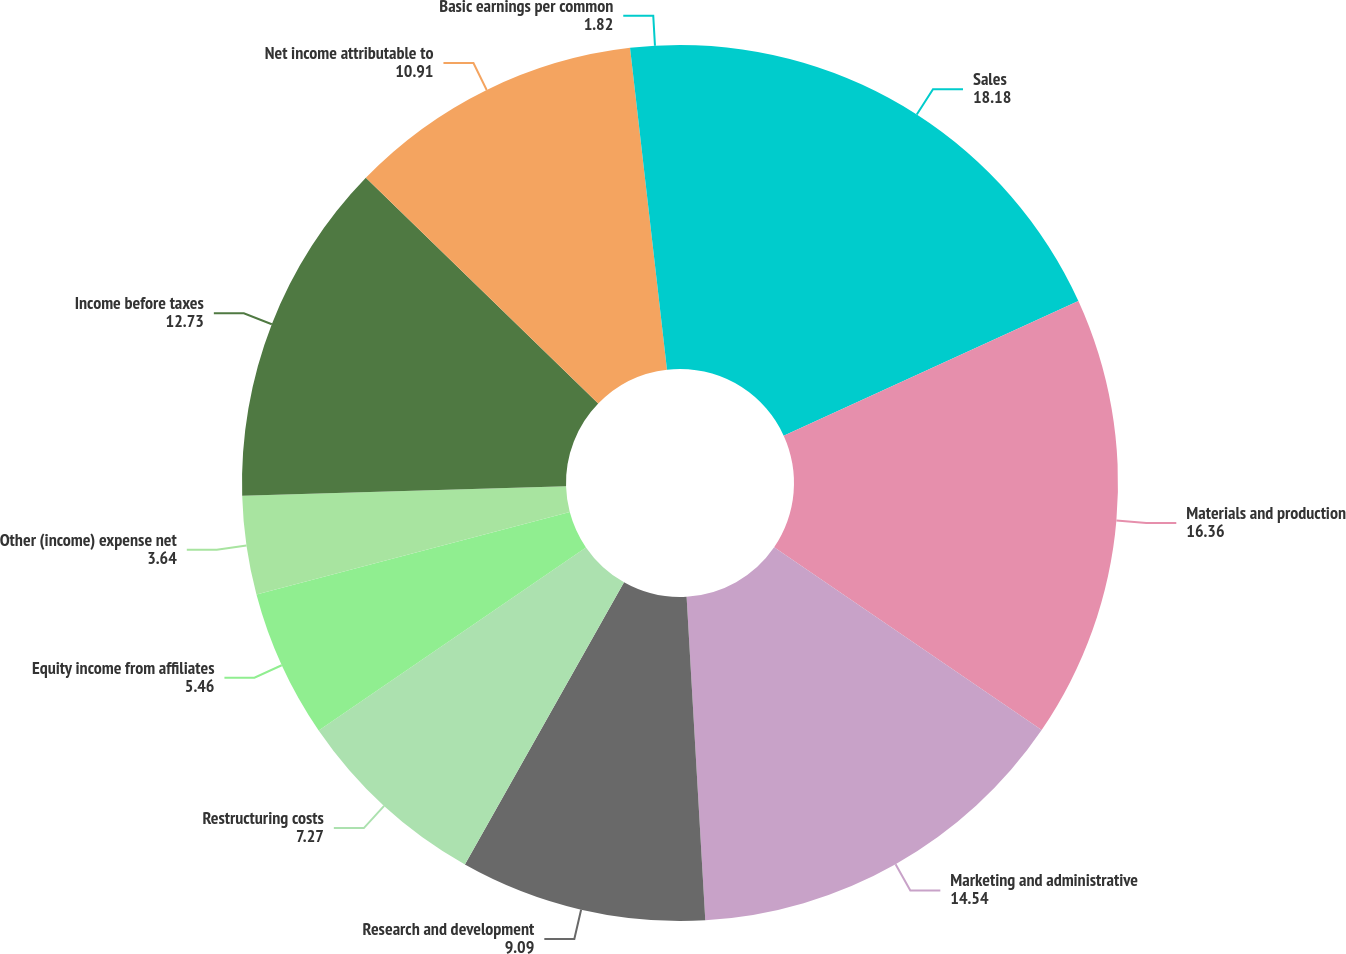Convert chart to OTSL. <chart><loc_0><loc_0><loc_500><loc_500><pie_chart><fcel>Sales<fcel>Materials and production<fcel>Marketing and administrative<fcel>Research and development<fcel>Restructuring costs<fcel>Equity income from affiliates<fcel>Other (income) expense net<fcel>Income before taxes<fcel>Net income attributable to<fcel>Basic earnings per common<nl><fcel>18.18%<fcel>16.36%<fcel>14.54%<fcel>9.09%<fcel>7.27%<fcel>5.46%<fcel>3.64%<fcel>12.73%<fcel>10.91%<fcel>1.82%<nl></chart> 